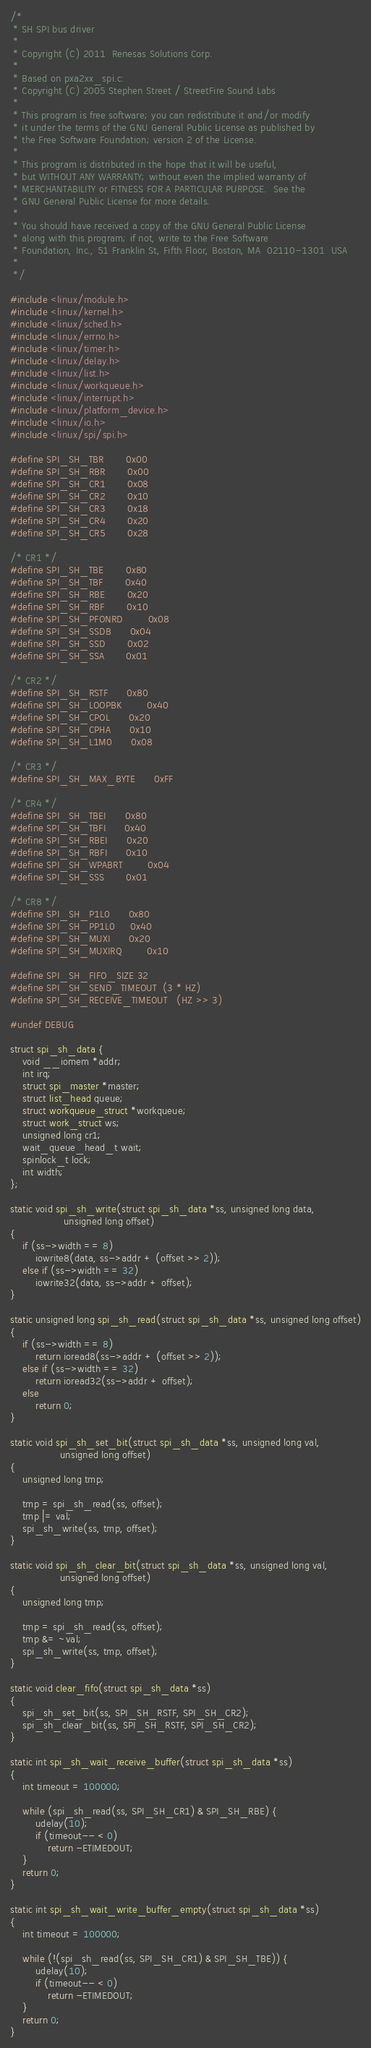Convert code to text. <code><loc_0><loc_0><loc_500><loc_500><_C_>/*
 * SH SPI bus driver
 *
 * Copyright (C) 2011  Renesas Solutions Corp.
 *
 * Based on pxa2xx_spi.c:
 * Copyright (C) 2005 Stephen Street / StreetFire Sound Labs
 *
 * This program is free software; you can redistribute it and/or modify
 * it under the terms of the GNU General Public License as published by
 * the Free Software Foundation; version 2 of the License.
 *
 * This program is distributed in the hope that it will be useful,
 * but WITHOUT ANY WARRANTY; without even the implied warranty of
 * MERCHANTABILITY or FITNESS FOR A PARTICULAR PURPOSE.  See the
 * GNU General Public License for more details.
 *
 * You should have received a copy of the GNU General Public License
 * along with this program; if not, write to the Free Software
 * Foundation, Inc., 51 Franklin St, Fifth Floor, Boston, MA  02110-1301  USA
 *
 */

#include <linux/module.h>
#include <linux/kernel.h>
#include <linux/sched.h>
#include <linux/errno.h>
#include <linux/timer.h>
#include <linux/delay.h>
#include <linux/list.h>
#include <linux/workqueue.h>
#include <linux/interrupt.h>
#include <linux/platform_device.h>
#include <linux/io.h>
#include <linux/spi/spi.h>

#define SPI_SH_TBR		0x00
#define SPI_SH_RBR		0x00
#define SPI_SH_CR1		0x08
#define SPI_SH_CR2		0x10
#define SPI_SH_CR3		0x18
#define SPI_SH_CR4		0x20
#define SPI_SH_CR5		0x28

/* CR1 */
#define SPI_SH_TBE		0x80
#define SPI_SH_TBF		0x40
#define SPI_SH_RBE		0x20
#define SPI_SH_RBF		0x10
#define SPI_SH_PFONRD		0x08
#define SPI_SH_SSDB		0x04
#define SPI_SH_SSD		0x02
#define SPI_SH_SSA		0x01

/* CR2 */
#define SPI_SH_RSTF		0x80
#define SPI_SH_LOOPBK		0x40
#define SPI_SH_CPOL		0x20
#define SPI_SH_CPHA		0x10
#define SPI_SH_L1M0		0x08

/* CR3 */
#define SPI_SH_MAX_BYTE		0xFF

/* CR4 */
#define SPI_SH_TBEI		0x80
#define SPI_SH_TBFI		0x40
#define SPI_SH_RBEI		0x20
#define SPI_SH_RBFI		0x10
#define SPI_SH_WPABRT		0x04
#define SPI_SH_SSS		0x01

/* CR8 */
#define SPI_SH_P1L0		0x80
#define SPI_SH_PP1L0		0x40
#define SPI_SH_MUXI		0x20
#define SPI_SH_MUXIRQ		0x10

#define SPI_SH_FIFO_SIZE	32
#define SPI_SH_SEND_TIMEOUT	(3 * HZ)
#define SPI_SH_RECEIVE_TIMEOUT	(HZ >> 3)

#undef DEBUG

struct spi_sh_data {
	void __iomem *addr;
	int irq;
	struct spi_master *master;
	struct list_head queue;
	struct workqueue_struct *workqueue;
	struct work_struct ws;
	unsigned long cr1;
	wait_queue_head_t wait;
	spinlock_t lock;
	int width;
};

static void spi_sh_write(struct spi_sh_data *ss, unsigned long data,
			     unsigned long offset)
{
	if (ss->width == 8)
		iowrite8(data, ss->addr + (offset >> 2));
	else if (ss->width == 32)
		iowrite32(data, ss->addr + offset);
}

static unsigned long spi_sh_read(struct spi_sh_data *ss, unsigned long offset)
{
	if (ss->width == 8)
		return ioread8(ss->addr + (offset >> 2));
	else if (ss->width == 32)
		return ioread32(ss->addr + offset);
	else
		return 0;
}

static void spi_sh_set_bit(struct spi_sh_data *ss, unsigned long val,
				unsigned long offset)
{
	unsigned long tmp;

	tmp = spi_sh_read(ss, offset);
	tmp |= val;
	spi_sh_write(ss, tmp, offset);
}

static void spi_sh_clear_bit(struct spi_sh_data *ss, unsigned long val,
				unsigned long offset)
{
	unsigned long tmp;

	tmp = spi_sh_read(ss, offset);
	tmp &= ~val;
	spi_sh_write(ss, tmp, offset);
}

static void clear_fifo(struct spi_sh_data *ss)
{
	spi_sh_set_bit(ss, SPI_SH_RSTF, SPI_SH_CR2);
	spi_sh_clear_bit(ss, SPI_SH_RSTF, SPI_SH_CR2);
}

static int spi_sh_wait_receive_buffer(struct spi_sh_data *ss)
{
	int timeout = 100000;

	while (spi_sh_read(ss, SPI_SH_CR1) & SPI_SH_RBE) {
		udelay(10);
		if (timeout-- < 0)
			return -ETIMEDOUT;
	}
	return 0;
}

static int spi_sh_wait_write_buffer_empty(struct spi_sh_data *ss)
{
	int timeout = 100000;

	while (!(spi_sh_read(ss, SPI_SH_CR1) & SPI_SH_TBE)) {
		udelay(10);
		if (timeout-- < 0)
			return -ETIMEDOUT;
	}
	return 0;
}
</code> 